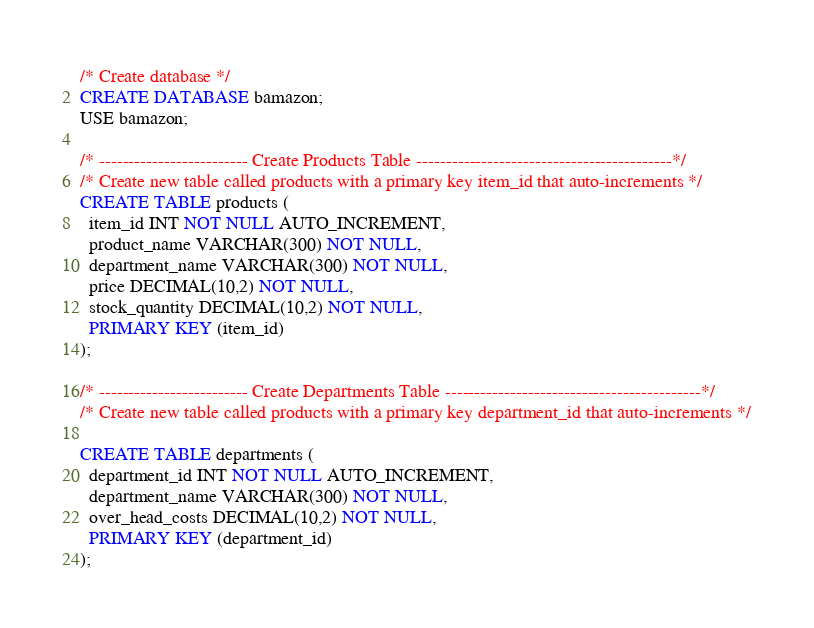Convert code to text. <code><loc_0><loc_0><loc_500><loc_500><_SQL_>/* Create database */
CREATE DATABASE bamazon;
USE bamazon;

/* ------------------------- Create Products Table -------------------------------------------*/
/* Create new table called products with a primary key item_id that auto-increments */
CREATE TABLE products (
  item_id INT NOT NULL AUTO_INCREMENT,
  product_name VARCHAR(300) NOT NULL,
  department_name VARCHAR(300) NOT NULL,
  price DECIMAL(10,2) NOT NULL,
  stock_quantity DECIMAL(10,2) NOT NULL,
  PRIMARY KEY (item_id)
);

/* ------------------------- Create Departments Table -------------------------------------------*/
/* Create new table called products with a primary key department_id that auto-increments */

CREATE TABLE departments (
  department_id INT NOT NULL AUTO_INCREMENT,
  department_name VARCHAR(300) NOT NULL,
  over_head_costs DECIMAL(10,2) NOT NULL,
  PRIMARY KEY (department_id)
);</code> 